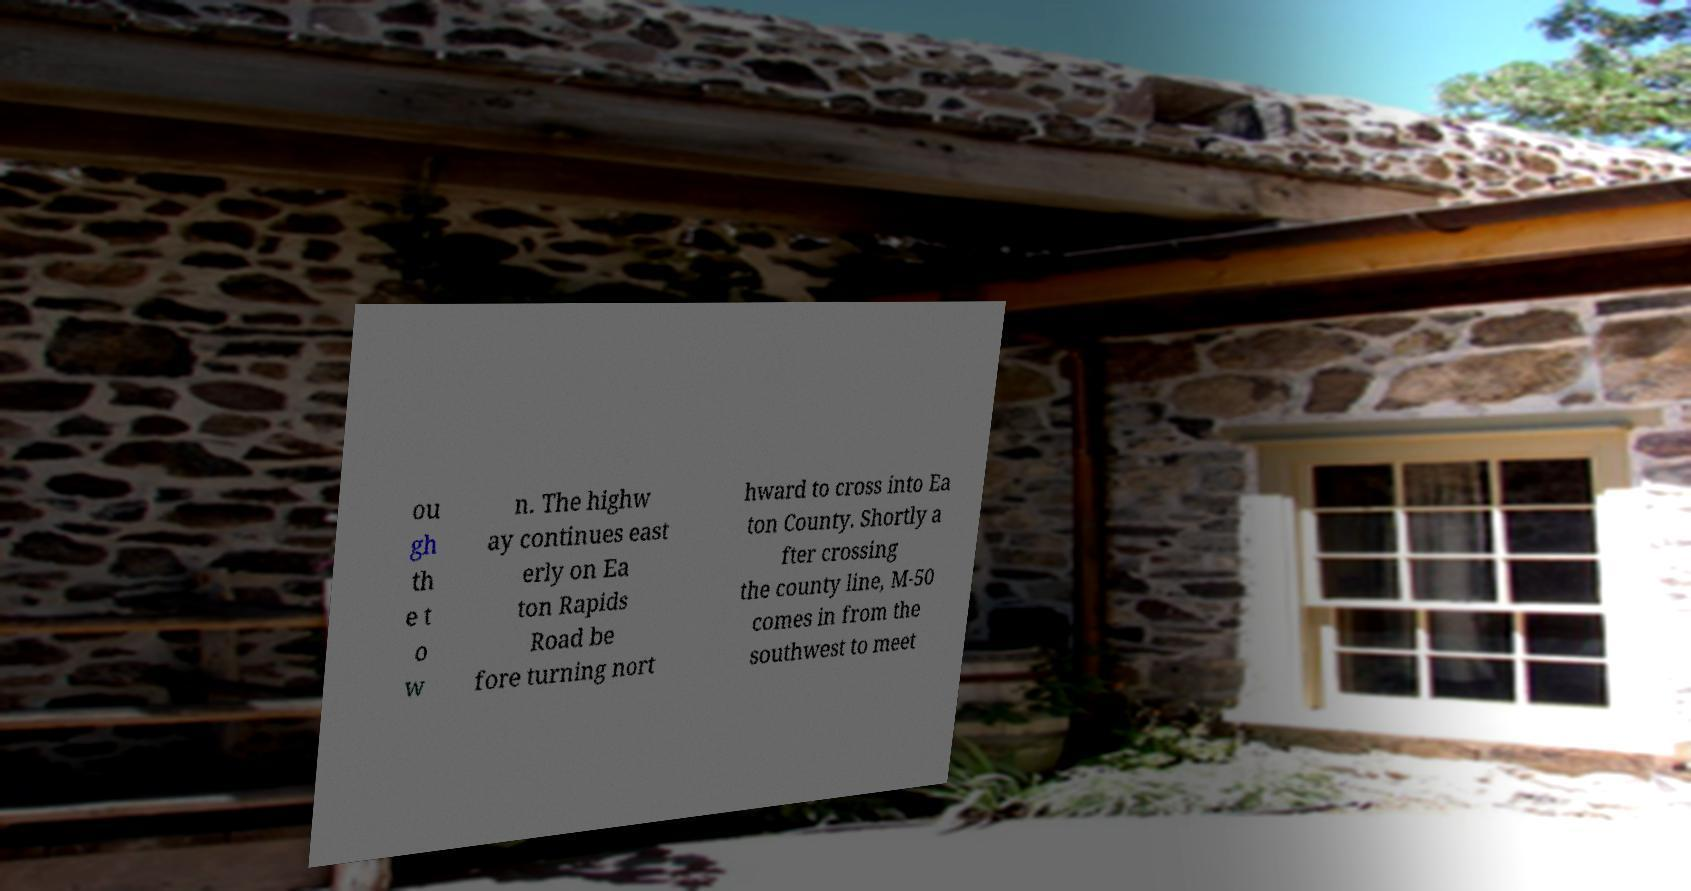What messages or text are displayed in this image? I need them in a readable, typed format. ou gh th e t o w n. The highw ay continues east erly on Ea ton Rapids Road be fore turning nort hward to cross into Ea ton County. Shortly a fter crossing the county line, M-50 comes in from the southwest to meet 